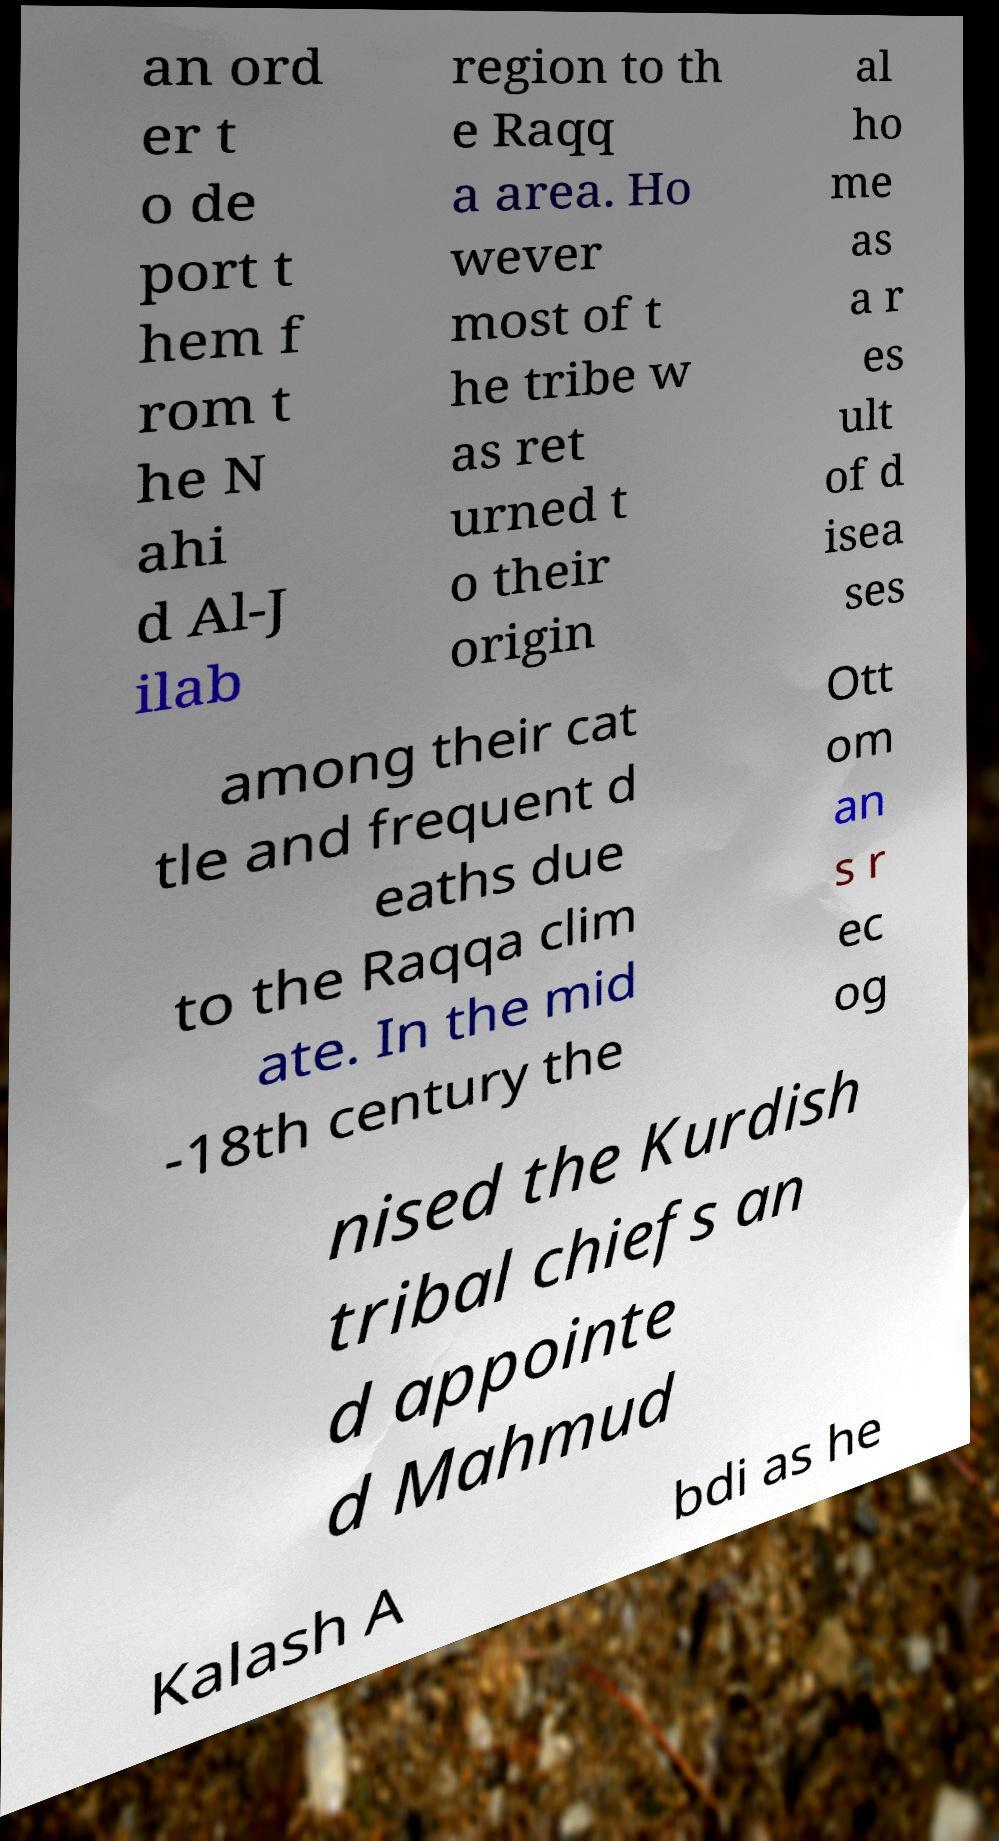For documentation purposes, I need the text within this image transcribed. Could you provide that? an ord er t o de port t hem f rom t he N ahi d Al-J ilab region to th e Raqq a area. Ho wever most of t he tribe w as ret urned t o their origin al ho me as a r es ult of d isea ses among their cat tle and frequent d eaths due to the Raqqa clim ate. In the mid -18th century the Ott om an s r ec og nised the Kurdish tribal chiefs an d appointe d Mahmud Kalash A bdi as he 